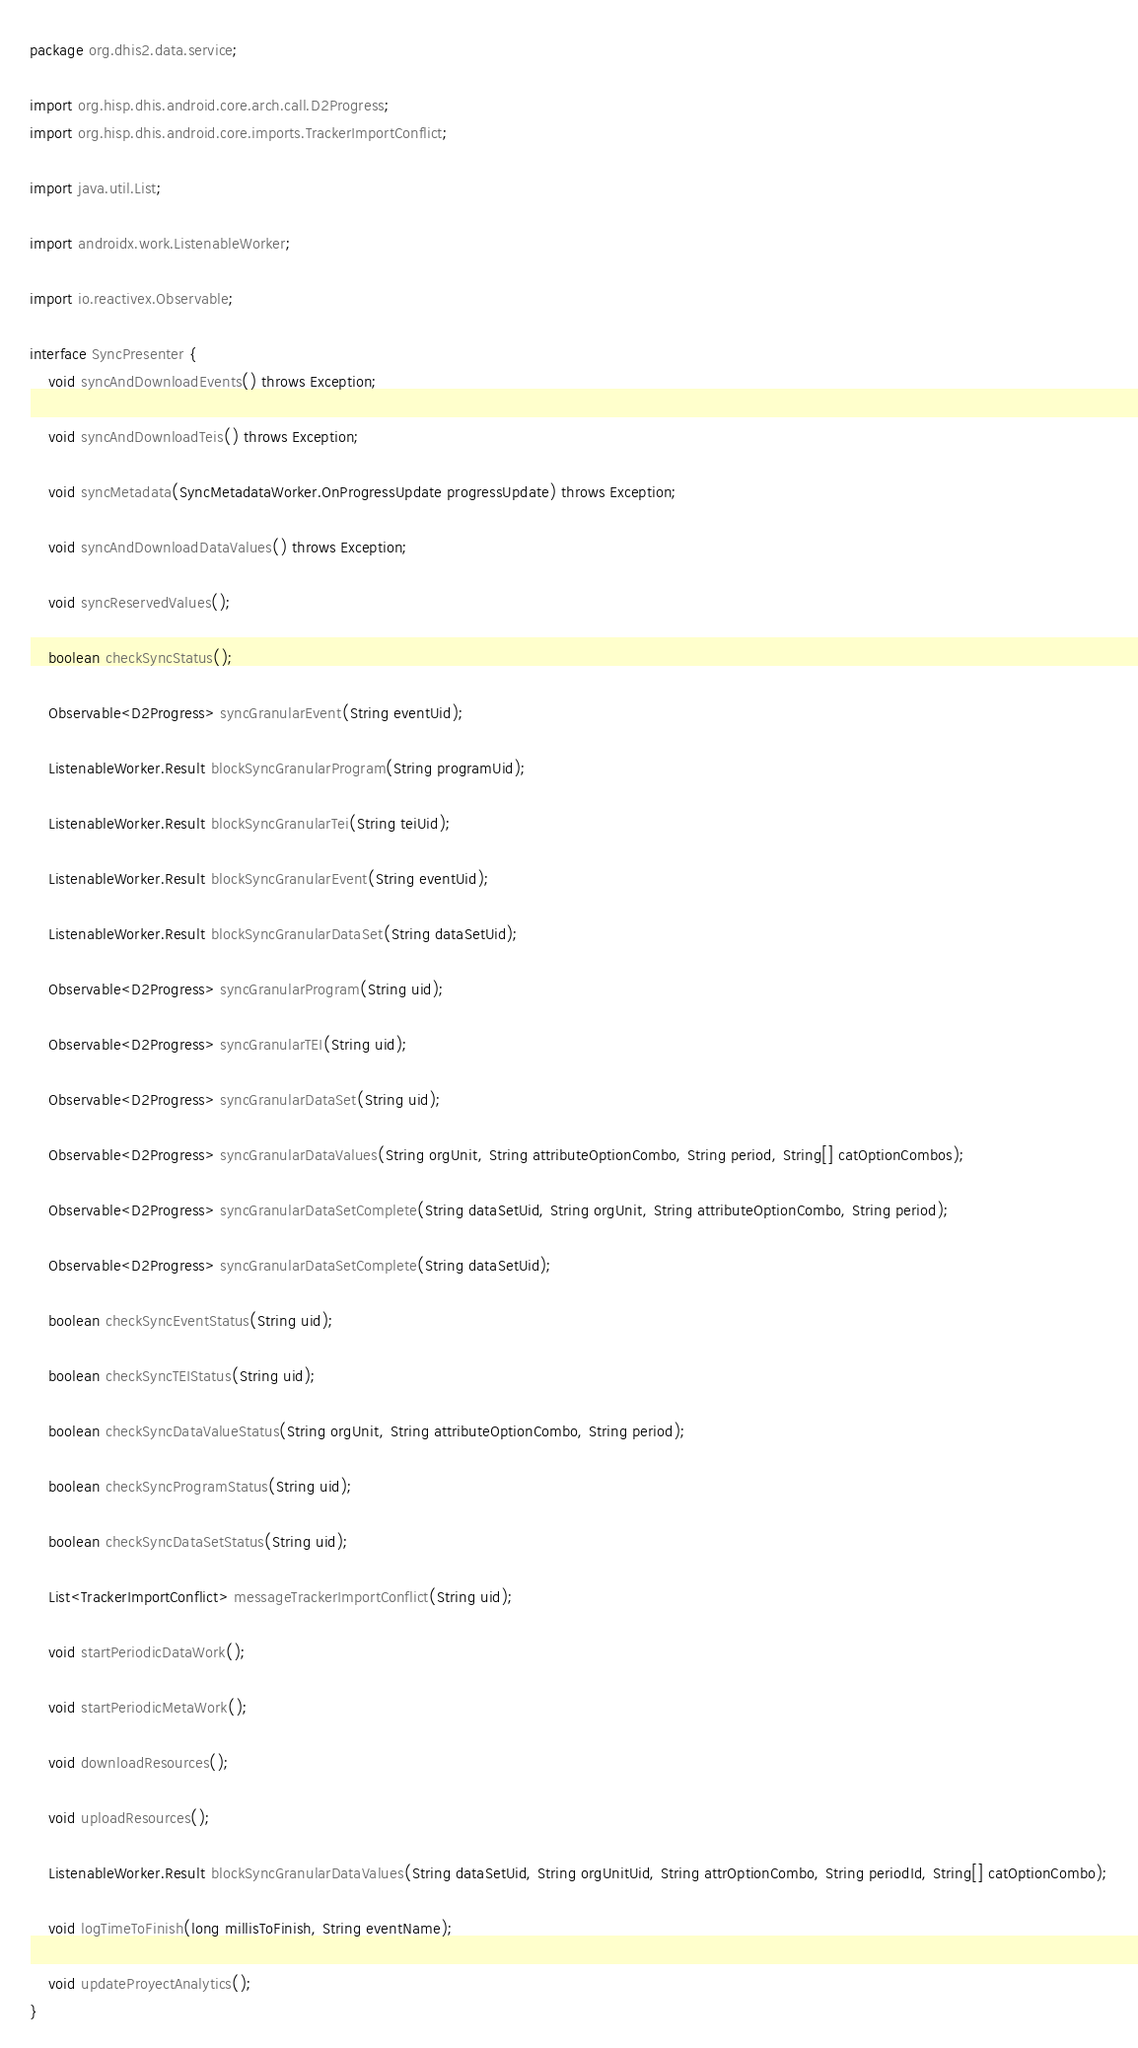Convert code to text. <code><loc_0><loc_0><loc_500><loc_500><_Java_>package org.dhis2.data.service;

import org.hisp.dhis.android.core.arch.call.D2Progress;
import org.hisp.dhis.android.core.imports.TrackerImportConflict;

import java.util.List;

import androidx.work.ListenableWorker;

import io.reactivex.Observable;

interface SyncPresenter {
    void syncAndDownloadEvents() throws Exception;

    void syncAndDownloadTeis() throws Exception;

    void syncMetadata(SyncMetadataWorker.OnProgressUpdate progressUpdate) throws Exception;

    void syncAndDownloadDataValues() throws Exception;

    void syncReservedValues();

    boolean checkSyncStatus();

    Observable<D2Progress> syncGranularEvent(String eventUid);

    ListenableWorker.Result blockSyncGranularProgram(String programUid);

    ListenableWorker.Result blockSyncGranularTei(String teiUid);

    ListenableWorker.Result blockSyncGranularEvent(String eventUid);

    ListenableWorker.Result blockSyncGranularDataSet(String dataSetUid);

    Observable<D2Progress> syncGranularProgram(String uid);

    Observable<D2Progress> syncGranularTEI(String uid);

    Observable<D2Progress> syncGranularDataSet(String uid);

    Observable<D2Progress> syncGranularDataValues(String orgUnit, String attributeOptionCombo, String period, String[] catOptionCombos);

    Observable<D2Progress> syncGranularDataSetComplete(String dataSetUid, String orgUnit, String attributeOptionCombo, String period);

    Observable<D2Progress> syncGranularDataSetComplete(String dataSetUid);

    boolean checkSyncEventStatus(String uid);

    boolean checkSyncTEIStatus(String uid);

    boolean checkSyncDataValueStatus(String orgUnit, String attributeOptionCombo, String period);

    boolean checkSyncProgramStatus(String uid);

    boolean checkSyncDataSetStatus(String uid);

    List<TrackerImportConflict> messageTrackerImportConflict(String uid);

    void startPeriodicDataWork();

    void startPeriodicMetaWork();

    void downloadResources();

    void uploadResources();

    ListenableWorker.Result blockSyncGranularDataValues(String dataSetUid, String orgUnitUid, String attrOptionCombo, String periodId, String[] catOptionCombo);

    void logTimeToFinish(long millisToFinish, String eventName);

    void updateProyectAnalytics();
}
</code> 